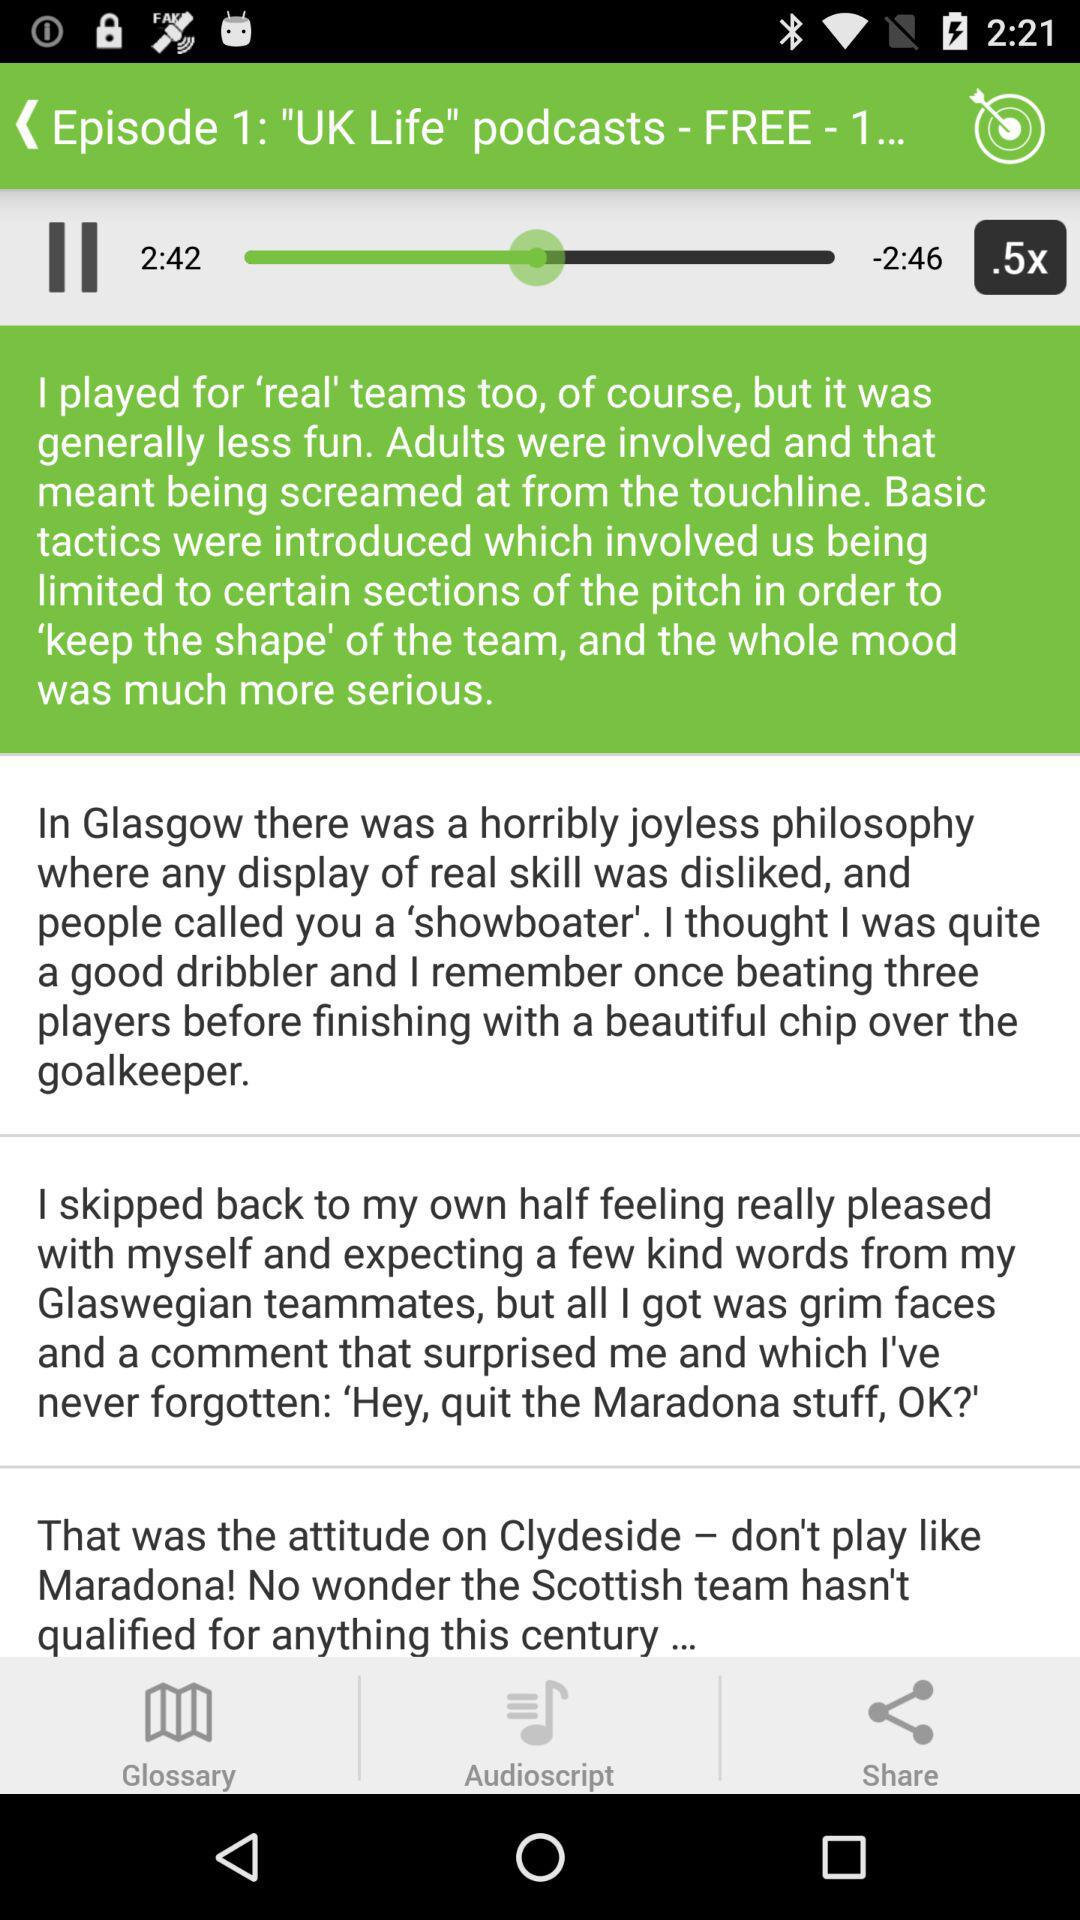Which tab is selected? The selected tab is "DETAILS". 